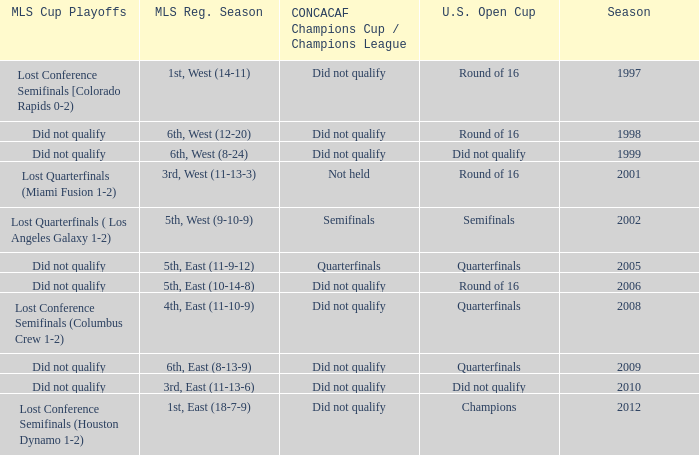When was the first season? 1997.0. Would you be able to parse every entry in this table? {'header': ['MLS Cup Playoffs', 'MLS Reg. Season', 'CONCACAF Champions Cup / Champions League', 'U.S. Open Cup', 'Season'], 'rows': [['Lost Conference Semifinals [Colorado Rapids 0-2)', '1st, West (14-11)', 'Did not qualify', 'Round of 16', '1997'], ['Did not qualify', '6th, West (12-20)', 'Did not qualify', 'Round of 16', '1998'], ['Did not qualify', '6th, West (8-24)', 'Did not qualify', 'Did not qualify', '1999'], ['Lost Quarterfinals (Miami Fusion 1-2)', '3rd, West (11-13-3)', 'Not held', 'Round of 16', '2001'], ['Lost Quarterfinals ( Los Angeles Galaxy 1-2)', '5th, West (9-10-9)', 'Semifinals', 'Semifinals', '2002'], ['Did not qualify', '5th, East (11-9-12)', 'Quarterfinals', 'Quarterfinals', '2005'], ['Did not qualify', '5th, East (10-14-8)', 'Did not qualify', 'Round of 16', '2006'], ['Lost Conference Semifinals (Columbus Crew 1-2)', '4th, East (11-10-9)', 'Did not qualify', 'Quarterfinals', '2008'], ['Did not qualify', '6th, East (8-13-9)', 'Did not qualify', 'Quarterfinals', '2009'], ['Did not qualify', '3rd, East (11-13-6)', 'Did not qualify', 'Did not qualify', '2010'], ['Lost Conference Semifinals (Houston Dynamo 1-2)', '1st, East (18-7-9)', 'Did not qualify', 'Champions', '2012']]} 